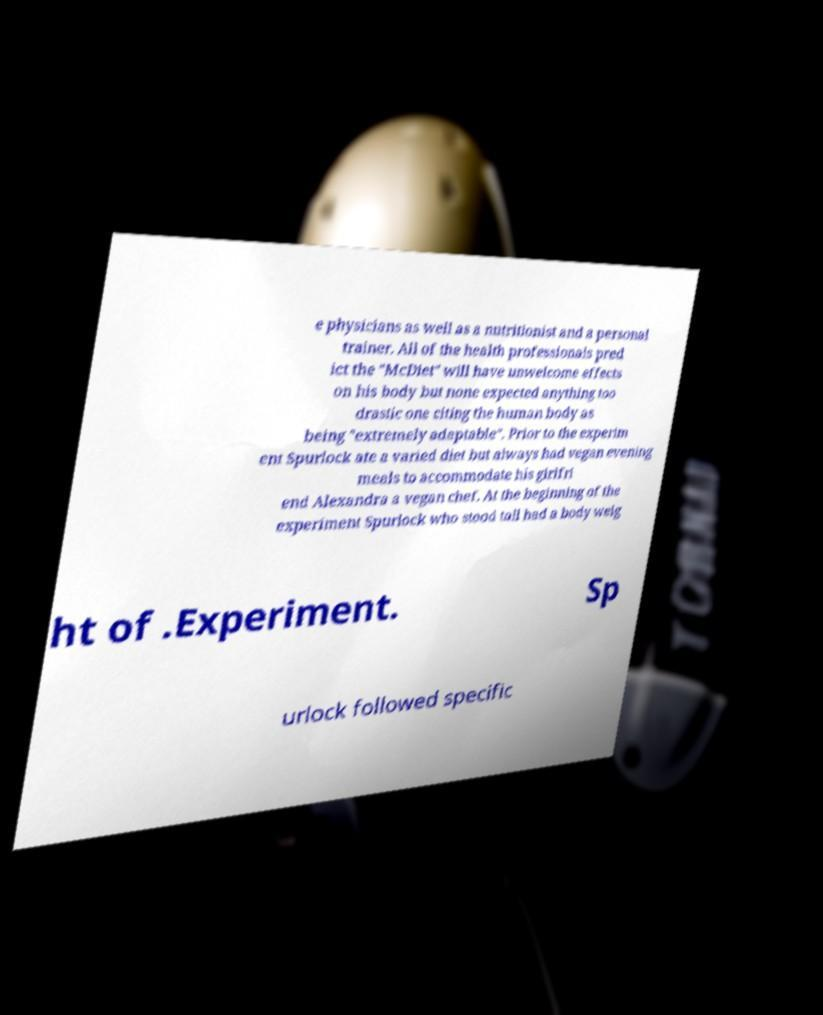Can you accurately transcribe the text from the provided image for me? e physicians as well as a nutritionist and a personal trainer. All of the health professionals pred ict the "McDiet" will have unwelcome effects on his body but none expected anything too drastic one citing the human body as being "extremely adaptable". Prior to the experim ent Spurlock ate a varied diet but always had vegan evening meals to accommodate his girlfri end Alexandra a vegan chef. At the beginning of the experiment Spurlock who stood tall had a body weig ht of .Experiment. Sp urlock followed specific 